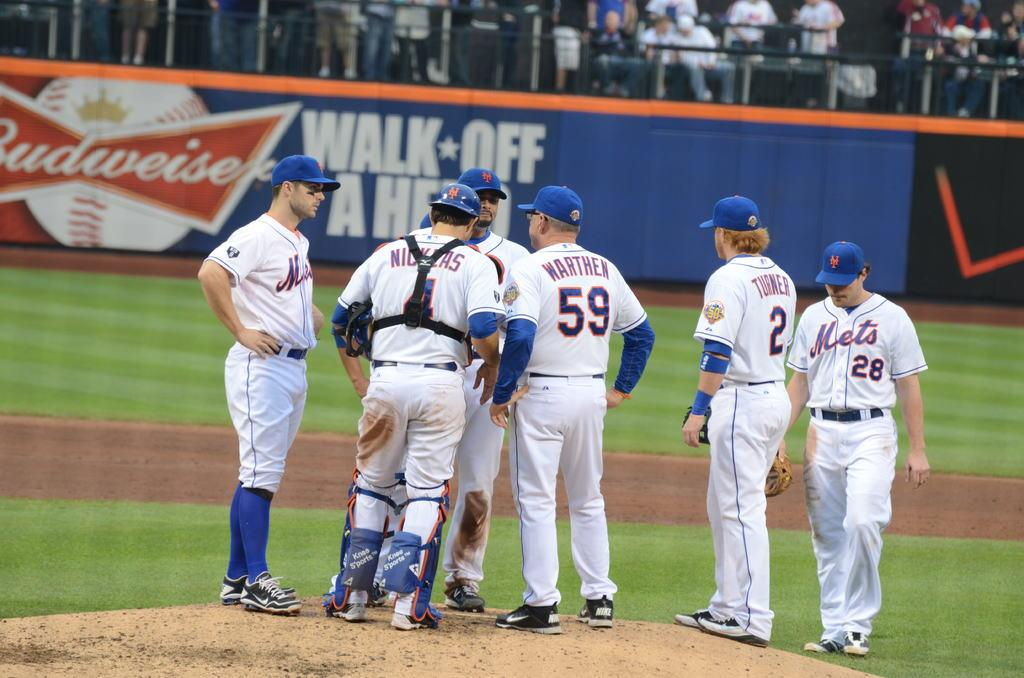Provide a one-sentence caption for the provided image. Group of players huddling up with number 59 in the middle. 